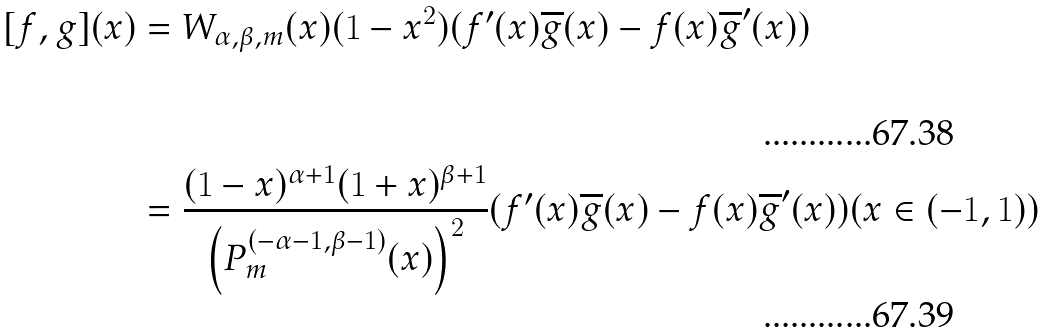<formula> <loc_0><loc_0><loc_500><loc_500>[ f , g ] ( x ) & = W _ { \alpha , \beta , m } ( x ) ( 1 - x ^ { 2 } ) ( f ^ { \prime } ( x ) \overline { g } ( x ) - f ( x ) \overline { g } ^ { \prime } ( x ) ) \\ & = \frac { ( 1 - x ) ^ { \alpha + 1 } ( 1 + x ) ^ { \beta + 1 } } { \left ( P _ { m } ^ { ( - \alpha - 1 , \beta - 1 ) } ( x ) \right ) ^ { 2 } } ( f ^ { \prime } ( x ) \overline { g } ( x ) - f ( x ) \overline { g } ^ { \prime } ( x ) ) ( x \in ( - 1 , 1 ) ) \,</formula> 